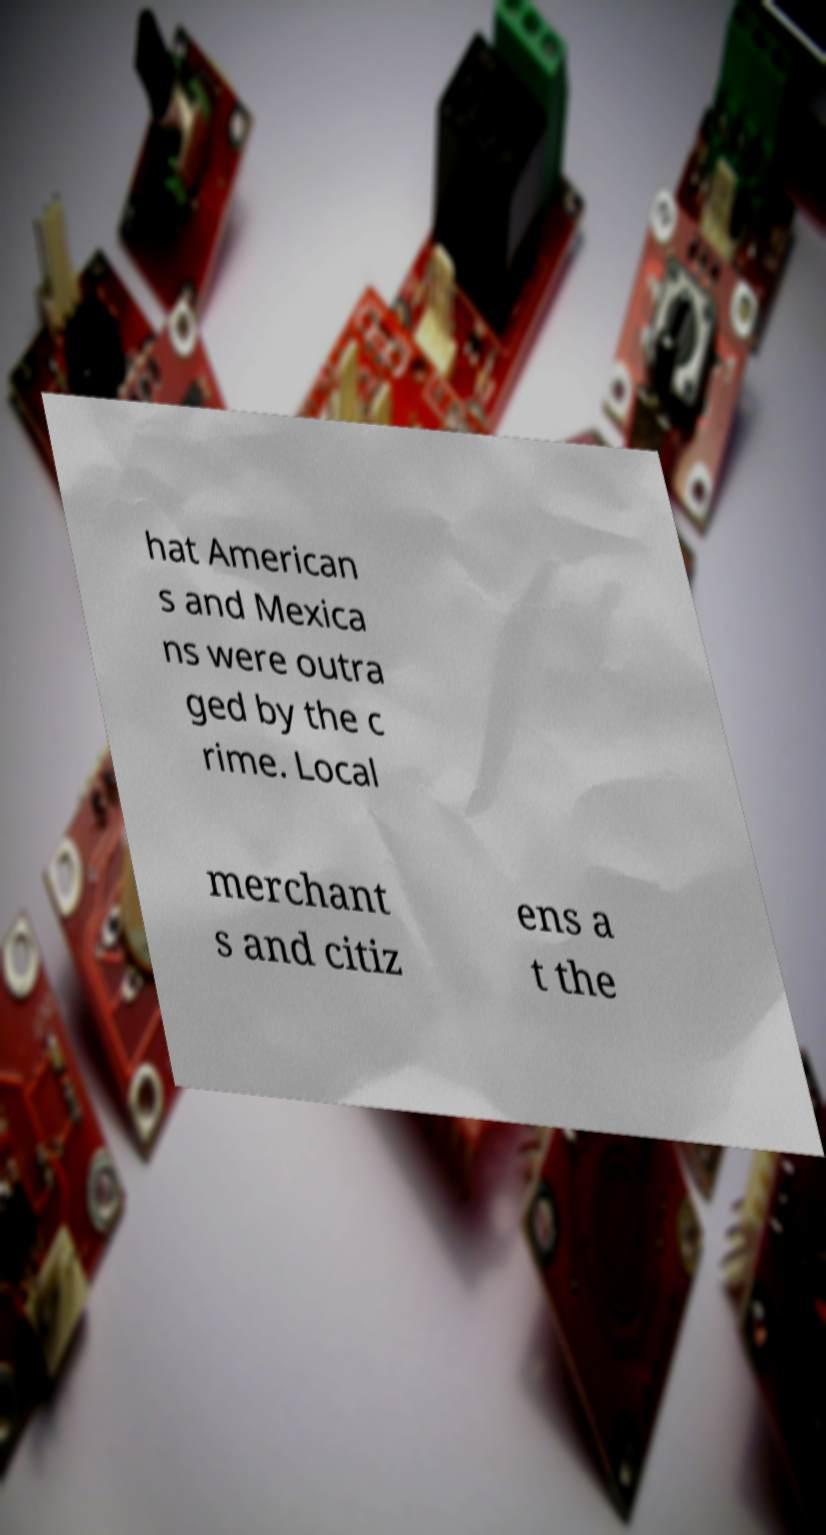Could you assist in decoding the text presented in this image and type it out clearly? hat American s and Mexica ns were outra ged by the c rime. Local merchant s and citiz ens a t the 